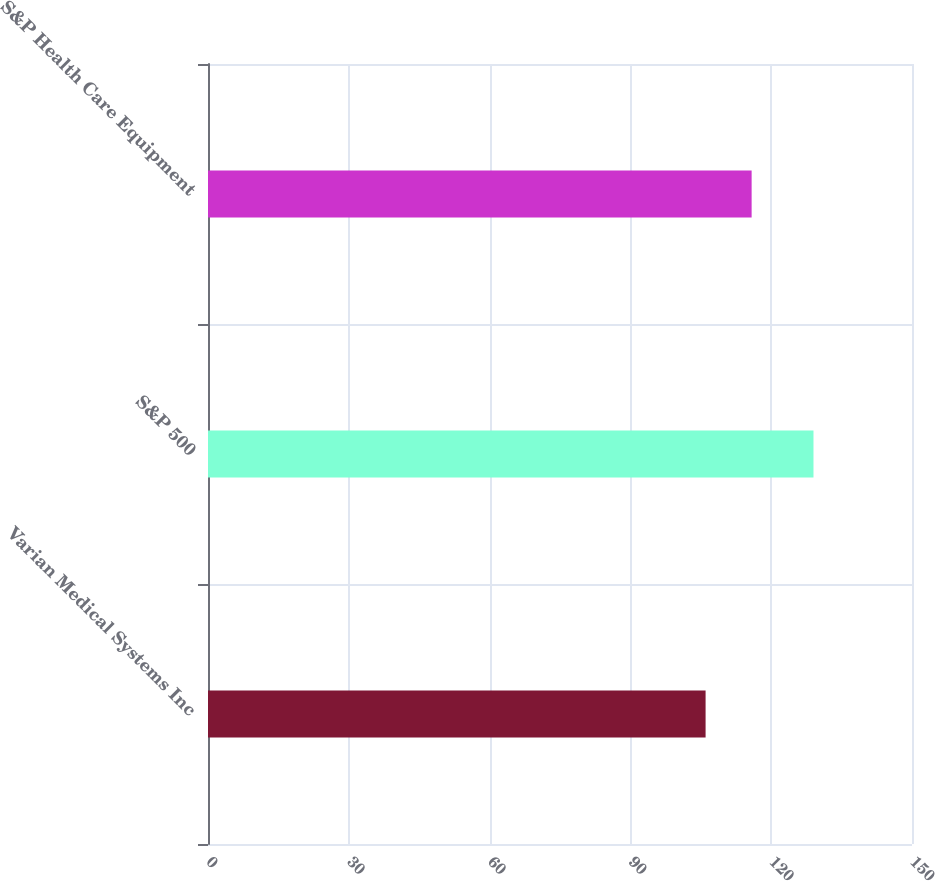<chart> <loc_0><loc_0><loc_500><loc_500><bar_chart><fcel>Varian Medical Systems Inc<fcel>S&P 500<fcel>S&P Health Care Equipment<nl><fcel>106.02<fcel>129.01<fcel>115.83<nl></chart> 